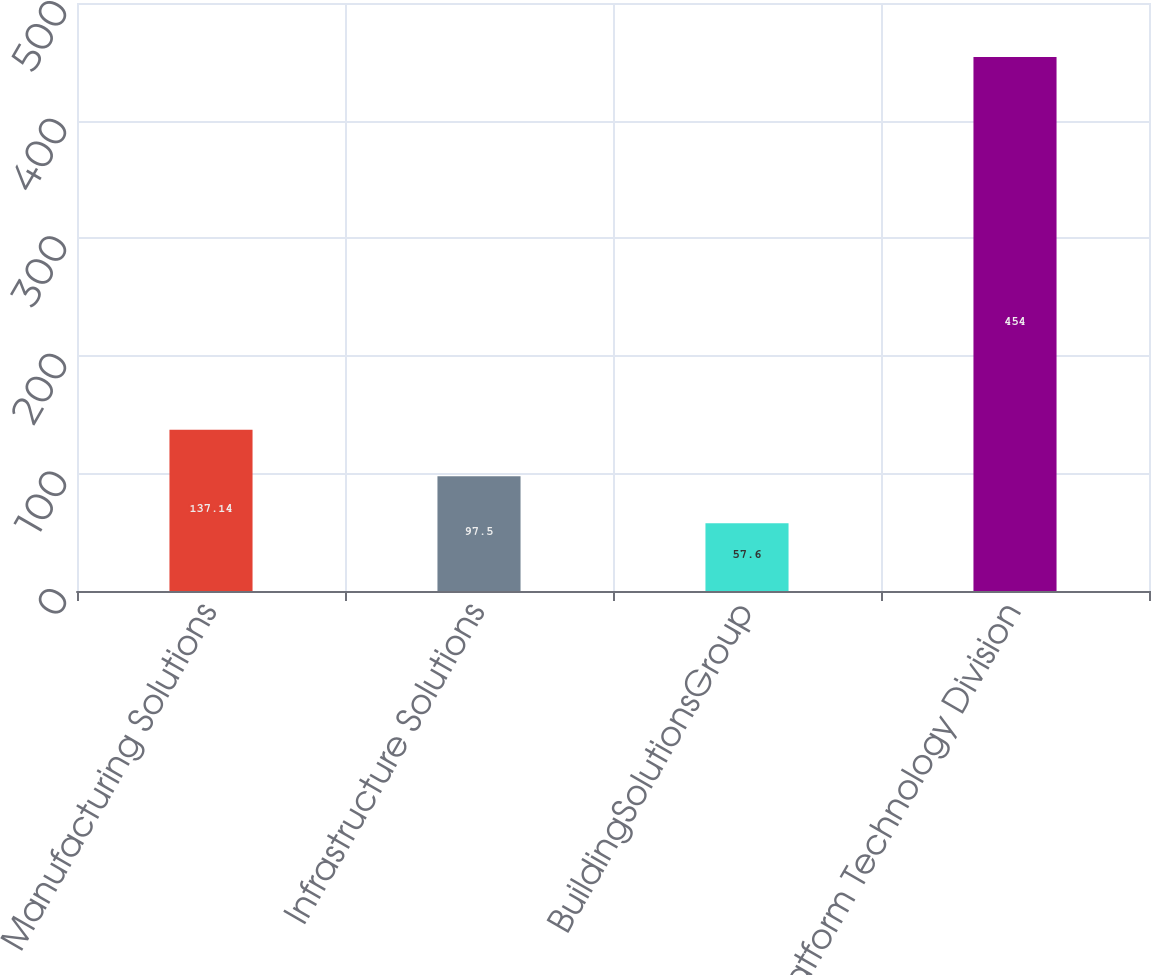Convert chart to OTSL. <chart><loc_0><loc_0><loc_500><loc_500><bar_chart><fcel>Manufacturing Solutions<fcel>Infrastructure Solutions<fcel>BuildingSolutionsGroup<fcel>Platform Technology Division<nl><fcel>137.14<fcel>97.5<fcel>57.6<fcel>454<nl></chart> 